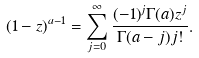<formula> <loc_0><loc_0><loc_500><loc_500>( 1 - z ) ^ { a - 1 } = \sum _ { j = 0 } ^ { \infty } \frac { ( - 1 ) ^ { j } \Gamma ( a ) z ^ { j } } { \Gamma ( a - j ) j ! } .</formula> 